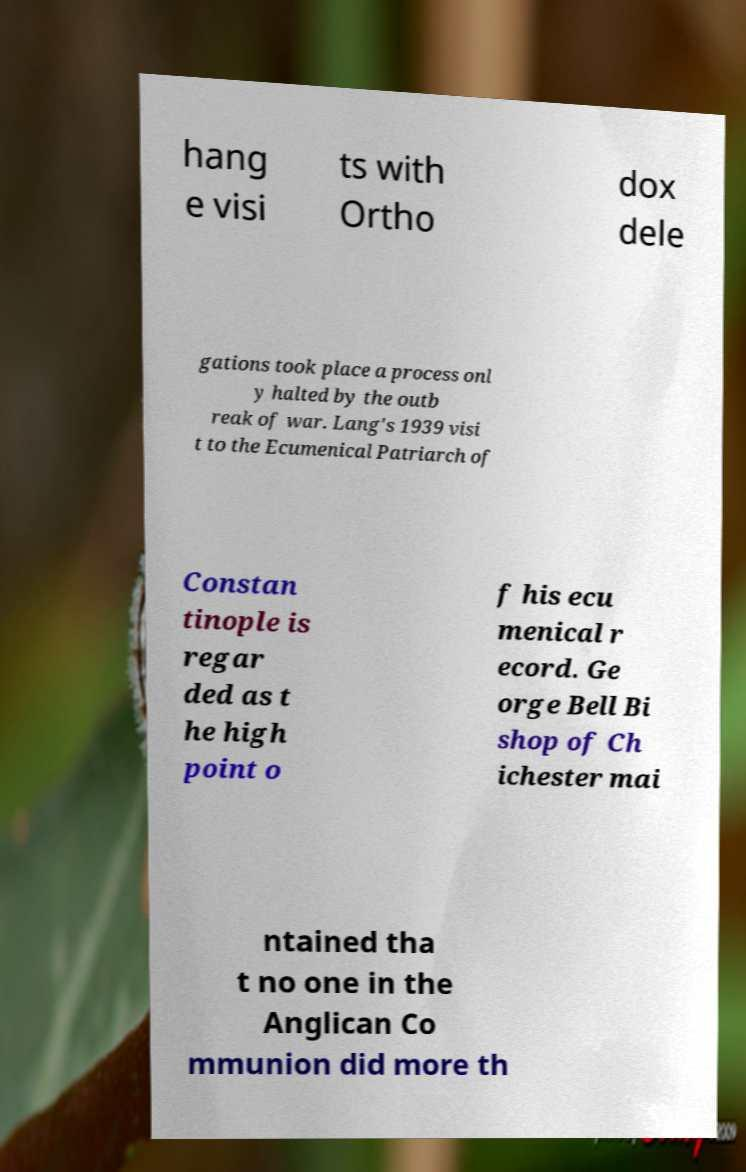There's text embedded in this image that I need extracted. Can you transcribe it verbatim? hang e visi ts with Ortho dox dele gations took place a process onl y halted by the outb reak of war. Lang's 1939 visi t to the Ecumenical Patriarch of Constan tinople is regar ded as t he high point o f his ecu menical r ecord. Ge orge Bell Bi shop of Ch ichester mai ntained tha t no one in the Anglican Co mmunion did more th 